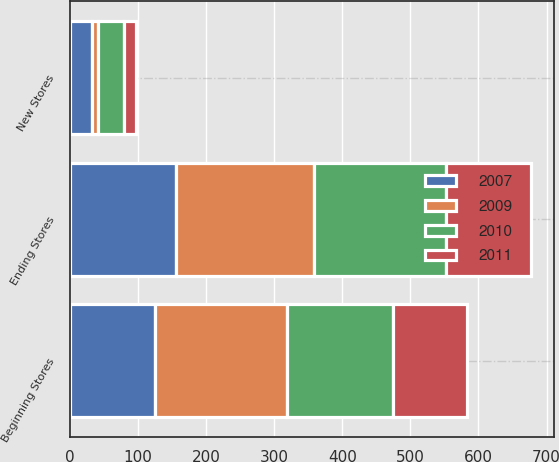Convert chart to OTSL. <chart><loc_0><loc_0><loc_500><loc_500><stacked_bar_chart><ecel><fcel>Beginning Stores<fcel>New Stores<fcel>Ending Stores<nl><fcel>2009<fcel>194<fcel>9<fcel>202<nl><fcel>2010<fcel>156<fcel>38<fcel>194<nl><fcel>2007<fcel>125<fcel>32<fcel>156<nl><fcel>2011<fcel>108<fcel>18<fcel>125<nl></chart> 